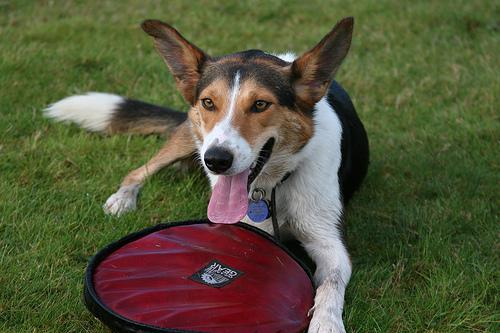Question: what is the dog doing?
Choices:
A. Laying on the grass.
B. Sleeping.
C. Eating.
D. Growling.
Answer with the letter. Answer: A Question: where is this picture taken?
Choices:
A. At the park.
B. On a grassy field.
C. Beach.
D. Mountain top.
Answer with the letter. Answer: B Question: what color is the dog?
Choices:
A. Grey.
B. Brown, black and white.
C. Silver.
D. Red.
Answer with the letter. Answer: B Question: why is the dog laying down?
Choices:
A. He's tired.
B. It is resting from playing frisbee.
C. By his master.
D. He's sleeping.
Answer with the letter. Answer: B Question: who threw the frisbee to the dog?
Choices:
A. Mom.
B. Dad.
C. The dog's owner.
D. I did.
Answer with the letter. Answer: C 